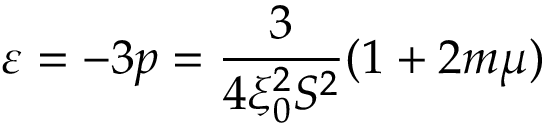<formula> <loc_0><loc_0><loc_500><loc_500>\varepsilon = - 3 p = \frac { 3 } { 4 \xi _ { 0 } ^ { 2 } S ^ { 2 } } ( 1 + 2 m \mu )</formula> 